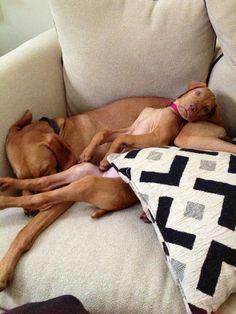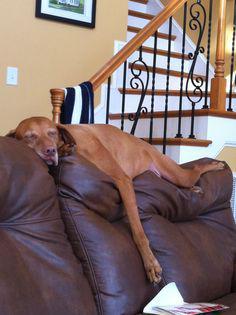The first image is the image on the left, the second image is the image on the right. Evaluate the accuracy of this statement regarding the images: "One dog is wearing a sweater.". Is it true? Answer yes or no. No. The first image is the image on the left, the second image is the image on the right. For the images shown, is this caption "One image shows a dog wearing a harness and the other shows a dog wearing a shirt." true? Answer yes or no. No. 